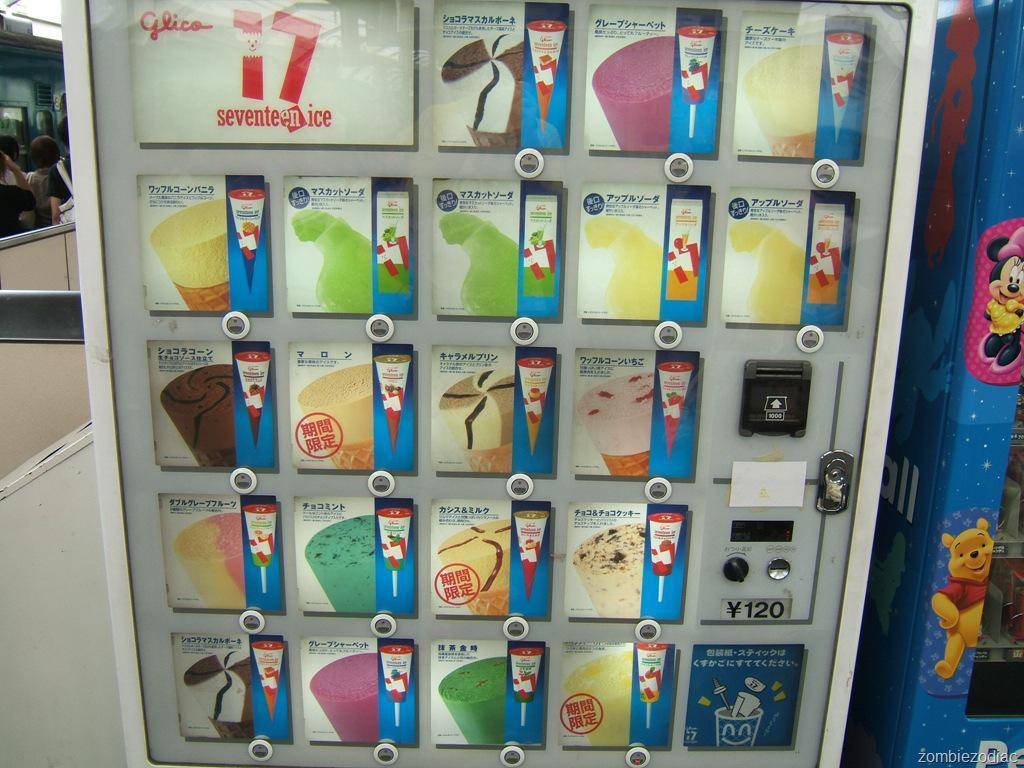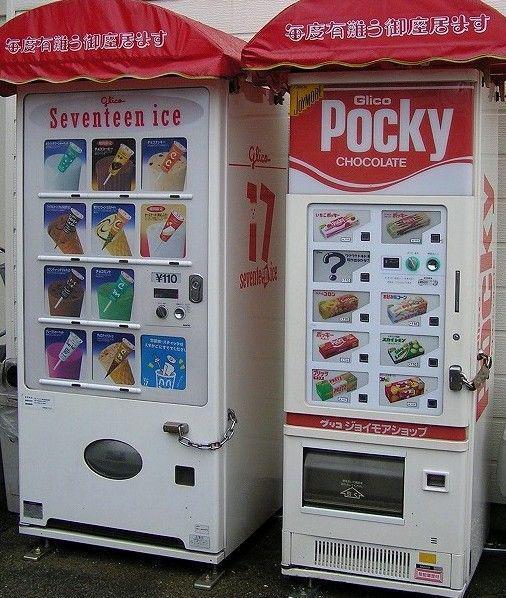The first image is the image on the left, the second image is the image on the right. For the images displayed, is the sentence "The dispensing port of the vending machine in the image on the right is oval." factually correct? Answer yes or no. Yes. 